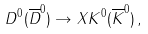<formula> <loc_0><loc_0><loc_500><loc_500>D ^ { 0 } ( \overline { D } ^ { 0 } ) \rightarrow X K ^ { 0 } ( \overline { K } ^ { 0 } ) \, ,</formula> 